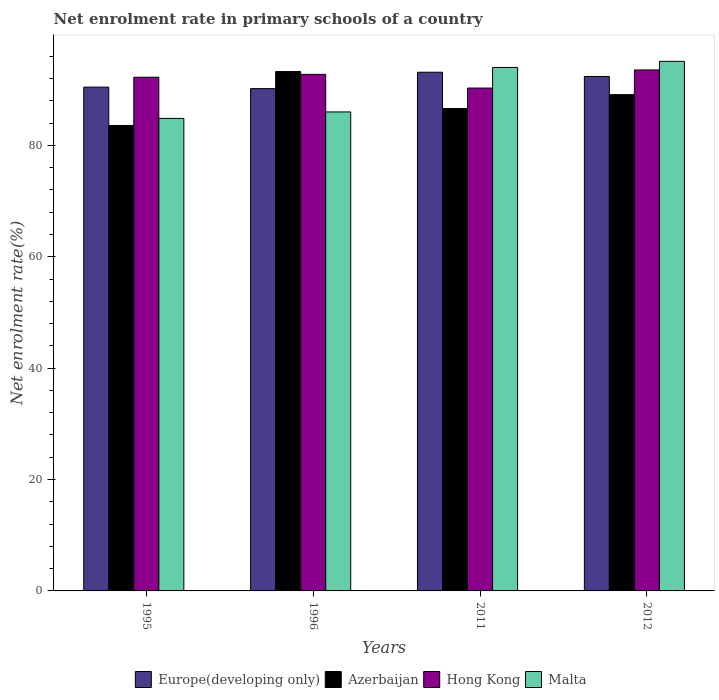How many groups of bars are there?
Provide a short and direct response. 4. Are the number of bars on each tick of the X-axis equal?
Ensure brevity in your answer.  Yes. What is the net enrolment rate in primary schools in Europe(developing only) in 2011?
Keep it short and to the point. 93.13. Across all years, what is the maximum net enrolment rate in primary schools in Hong Kong?
Make the answer very short. 93.54. Across all years, what is the minimum net enrolment rate in primary schools in Azerbaijan?
Provide a succinct answer. 83.57. In which year was the net enrolment rate in primary schools in Malta maximum?
Offer a terse response. 2012. In which year was the net enrolment rate in primary schools in Hong Kong minimum?
Your answer should be very brief. 2011. What is the total net enrolment rate in primary schools in Malta in the graph?
Offer a terse response. 359.91. What is the difference between the net enrolment rate in primary schools in Azerbaijan in 2011 and that in 2012?
Your answer should be compact. -2.49. What is the difference between the net enrolment rate in primary schools in Europe(developing only) in 2011 and the net enrolment rate in primary schools in Hong Kong in 2012?
Make the answer very short. -0.41. What is the average net enrolment rate in primary schools in Hong Kong per year?
Offer a terse response. 92.2. In the year 2011, what is the difference between the net enrolment rate in primary schools in Europe(developing only) and net enrolment rate in primary schools in Azerbaijan?
Ensure brevity in your answer.  6.52. What is the ratio of the net enrolment rate in primary schools in Malta in 1995 to that in 1996?
Offer a very short reply. 0.99. Is the difference between the net enrolment rate in primary schools in Europe(developing only) in 1996 and 2011 greater than the difference between the net enrolment rate in primary schools in Azerbaijan in 1996 and 2011?
Offer a very short reply. No. What is the difference between the highest and the second highest net enrolment rate in primary schools in Hong Kong?
Give a very brief answer. 0.79. What is the difference between the highest and the lowest net enrolment rate in primary schools in Malta?
Your response must be concise. 10.24. In how many years, is the net enrolment rate in primary schools in Malta greater than the average net enrolment rate in primary schools in Malta taken over all years?
Your response must be concise. 2. Is the sum of the net enrolment rate in primary schools in Malta in 1996 and 2011 greater than the maximum net enrolment rate in primary schools in Hong Kong across all years?
Your answer should be very brief. Yes. What does the 2nd bar from the left in 2012 represents?
Offer a very short reply. Azerbaijan. What does the 3rd bar from the right in 1995 represents?
Ensure brevity in your answer.  Azerbaijan. How many bars are there?
Offer a very short reply. 16. What is the difference between two consecutive major ticks on the Y-axis?
Your answer should be very brief. 20. Where does the legend appear in the graph?
Give a very brief answer. Bottom center. What is the title of the graph?
Make the answer very short. Net enrolment rate in primary schools of a country. What is the label or title of the Y-axis?
Provide a short and direct response. Net enrolment rate(%). What is the Net enrolment rate(%) of Europe(developing only) in 1995?
Make the answer very short. 90.46. What is the Net enrolment rate(%) of Azerbaijan in 1995?
Provide a succinct answer. 83.57. What is the Net enrolment rate(%) in Hong Kong in 1995?
Give a very brief answer. 92.23. What is the Net enrolment rate(%) in Malta in 1995?
Provide a succinct answer. 84.84. What is the Net enrolment rate(%) of Europe(developing only) in 1996?
Ensure brevity in your answer.  90.19. What is the Net enrolment rate(%) in Azerbaijan in 1996?
Ensure brevity in your answer.  93.25. What is the Net enrolment rate(%) of Hong Kong in 1996?
Provide a succinct answer. 92.74. What is the Net enrolment rate(%) in Malta in 1996?
Provide a succinct answer. 86. What is the Net enrolment rate(%) of Europe(developing only) in 2011?
Offer a very short reply. 93.13. What is the Net enrolment rate(%) in Azerbaijan in 2011?
Ensure brevity in your answer.  86.61. What is the Net enrolment rate(%) in Hong Kong in 2011?
Provide a short and direct response. 90.29. What is the Net enrolment rate(%) in Malta in 2011?
Keep it short and to the point. 93.99. What is the Net enrolment rate(%) of Europe(developing only) in 2012?
Your answer should be very brief. 92.37. What is the Net enrolment rate(%) in Azerbaijan in 2012?
Make the answer very short. 89.11. What is the Net enrolment rate(%) of Hong Kong in 2012?
Keep it short and to the point. 93.54. What is the Net enrolment rate(%) in Malta in 2012?
Offer a terse response. 95.08. Across all years, what is the maximum Net enrolment rate(%) in Europe(developing only)?
Make the answer very short. 93.13. Across all years, what is the maximum Net enrolment rate(%) in Azerbaijan?
Offer a terse response. 93.25. Across all years, what is the maximum Net enrolment rate(%) in Hong Kong?
Provide a succinct answer. 93.54. Across all years, what is the maximum Net enrolment rate(%) of Malta?
Your answer should be very brief. 95.08. Across all years, what is the minimum Net enrolment rate(%) of Europe(developing only)?
Provide a succinct answer. 90.19. Across all years, what is the minimum Net enrolment rate(%) in Azerbaijan?
Make the answer very short. 83.57. Across all years, what is the minimum Net enrolment rate(%) in Hong Kong?
Your answer should be very brief. 90.29. Across all years, what is the minimum Net enrolment rate(%) in Malta?
Make the answer very short. 84.84. What is the total Net enrolment rate(%) of Europe(developing only) in the graph?
Make the answer very short. 366.14. What is the total Net enrolment rate(%) of Azerbaijan in the graph?
Offer a terse response. 352.55. What is the total Net enrolment rate(%) of Hong Kong in the graph?
Provide a short and direct response. 368.8. What is the total Net enrolment rate(%) in Malta in the graph?
Your answer should be compact. 359.91. What is the difference between the Net enrolment rate(%) in Europe(developing only) in 1995 and that in 1996?
Provide a succinct answer. 0.27. What is the difference between the Net enrolment rate(%) in Azerbaijan in 1995 and that in 1996?
Ensure brevity in your answer.  -9.68. What is the difference between the Net enrolment rate(%) of Hong Kong in 1995 and that in 1996?
Provide a short and direct response. -0.51. What is the difference between the Net enrolment rate(%) of Malta in 1995 and that in 1996?
Offer a terse response. -1.16. What is the difference between the Net enrolment rate(%) of Europe(developing only) in 1995 and that in 2011?
Ensure brevity in your answer.  -2.67. What is the difference between the Net enrolment rate(%) of Azerbaijan in 1995 and that in 2011?
Ensure brevity in your answer.  -3.04. What is the difference between the Net enrolment rate(%) in Hong Kong in 1995 and that in 2011?
Make the answer very short. 1.95. What is the difference between the Net enrolment rate(%) in Malta in 1995 and that in 2011?
Ensure brevity in your answer.  -9.15. What is the difference between the Net enrolment rate(%) in Europe(developing only) in 1995 and that in 2012?
Keep it short and to the point. -1.91. What is the difference between the Net enrolment rate(%) of Azerbaijan in 1995 and that in 2012?
Keep it short and to the point. -5.53. What is the difference between the Net enrolment rate(%) in Hong Kong in 1995 and that in 2012?
Provide a succinct answer. -1.3. What is the difference between the Net enrolment rate(%) of Malta in 1995 and that in 2012?
Your answer should be very brief. -10.24. What is the difference between the Net enrolment rate(%) of Europe(developing only) in 1996 and that in 2011?
Offer a terse response. -2.94. What is the difference between the Net enrolment rate(%) in Azerbaijan in 1996 and that in 2011?
Make the answer very short. 6.64. What is the difference between the Net enrolment rate(%) in Hong Kong in 1996 and that in 2011?
Offer a very short reply. 2.46. What is the difference between the Net enrolment rate(%) in Malta in 1996 and that in 2011?
Make the answer very short. -7.98. What is the difference between the Net enrolment rate(%) of Europe(developing only) in 1996 and that in 2012?
Make the answer very short. -2.18. What is the difference between the Net enrolment rate(%) in Azerbaijan in 1996 and that in 2012?
Give a very brief answer. 4.15. What is the difference between the Net enrolment rate(%) in Hong Kong in 1996 and that in 2012?
Make the answer very short. -0.79. What is the difference between the Net enrolment rate(%) of Malta in 1996 and that in 2012?
Keep it short and to the point. -9.08. What is the difference between the Net enrolment rate(%) in Europe(developing only) in 2011 and that in 2012?
Offer a terse response. 0.76. What is the difference between the Net enrolment rate(%) in Azerbaijan in 2011 and that in 2012?
Keep it short and to the point. -2.49. What is the difference between the Net enrolment rate(%) of Hong Kong in 2011 and that in 2012?
Make the answer very short. -3.25. What is the difference between the Net enrolment rate(%) of Malta in 2011 and that in 2012?
Keep it short and to the point. -1.1. What is the difference between the Net enrolment rate(%) of Europe(developing only) in 1995 and the Net enrolment rate(%) of Azerbaijan in 1996?
Make the answer very short. -2.79. What is the difference between the Net enrolment rate(%) of Europe(developing only) in 1995 and the Net enrolment rate(%) of Hong Kong in 1996?
Ensure brevity in your answer.  -2.28. What is the difference between the Net enrolment rate(%) of Europe(developing only) in 1995 and the Net enrolment rate(%) of Malta in 1996?
Your answer should be very brief. 4.46. What is the difference between the Net enrolment rate(%) of Azerbaijan in 1995 and the Net enrolment rate(%) of Hong Kong in 1996?
Provide a short and direct response. -9.17. What is the difference between the Net enrolment rate(%) in Azerbaijan in 1995 and the Net enrolment rate(%) in Malta in 1996?
Ensure brevity in your answer.  -2.43. What is the difference between the Net enrolment rate(%) of Hong Kong in 1995 and the Net enrolment rate(%) of Malta in 1996?
Give a very brief answer. 6.23. What is the difference between the Net enrolment rate(%) of Europe(developing only) in 1995 and the Net enrolment rate(%) of Azerbaijan in 2011?
Make the answer very short. 3.85. What is the difference between the Net enrolment rate(%) of Europe(developing only) in 1995 and the Net enrolment rate(%) of Hong Kong in 2011?
Your answer should be very brief. 0.17. What is the difference between the Net enrolment rate(%) in Europe(developing only) in 1995 and the Net enrolment rate(%) in Malta in 2011?
Make the answer very short. -3.53. What is the difference between the Net enrolment rate(%) in Azerbaijan in 1995 and the Net enrolment rate(%) in Hong Kong in 2011?
Keep it short and to the point. -6.71. What is the difference between the Net enrolment rate(%) of Azerbaijan in 1995 and the Net enrolment rate(%) of Malta in 2011?
Give a very brief answer. -10.41. What is the difference between the Net enrolment rate(%) of Hong Kong in 1995 and the Net enrolment rate(%) of Malta in 2011?
Offer a very short reply. -1.75. What is the difference between the Net enrolment rate(%) of Europe(developing only) in 1995 and the Net enrolment rate(%) of Azerbaijan in 2012?
Provide a short and direct response. 1.35. What is the difference between the Net enrolment rate(%) in Europe(developing only) in 1995 and the Net enrolment rate(%) in Hong Kong in 2012?
Ensure brevity in your answer.  -3.08. What is the difference between the Net enrolment rate(%) of Europe(developing only) in 1995 and the Net enrolment rate(%) of Malta in 2012?
Offer a terse response. -4.62. What is the difference between the Net enrolment rate(%) of Azerbaijan in 1995 and the Net enrolment rate(%) of Hong Kong in 2012?
Ensure brevity in your answer.  -9.96. What is the difference between the Net enrolment rate(%) of Azerbaijan in 1995 and the Net enrolment rate(%) of Malta in 2012?
Provide a succinct answer. -11.51. What is the difference between the Net enrolment rate(%) of Hong Kong in 1995 and the Net enrolment rate(%) of Malta in 2012?
Give a very brief answer. -2.85. What is the difference between the Net enrolment rate(%) of Europe(developing only) in 1996 and the Net enrolment rate(%) of Azerbaijan in 2011?
Provide a short and direct response. 3.57. What is the difference between the Net enrolment rate(%) in Europe(developing only) in 1996 and the Net enrolment rate(%) in Hong Kong in 2011?
Offer a terse response. -0.1. What is the difference between the Net enrolment rate(%) of Europe(developing only) in 1996 and the Net enrolment rate(%) of Malta in 2011?
Offer a very short reply. -3.8. What is the difference between the Net enrolment rate(%) in Azerbaijan in 1996 and the Net enrolment rate(%) in Hong Kong in 2011?
Make the answer very short. 2.97. What is the difference between the Net enrolment rate(%) in Azerbaijan in 1996 and the Net enrolment rate(%) in Malta in 2011?
Provide a short and direct response. -0.73. What is the difference between the Net enrolment rate(%) in Hong Kong in 1996 and the Net enrolment rate(%) in Malta in 2011?
Keep it short and to the point. -1.24. What is the difference between the Net enrolment rate(%) in Europe(developing only) in 1996 and the Net enrolment rate(%) in Azerbaijan in 2012?
Your response must be concise. 1.08. What is the difference between the Net enrolment rate(%) in Europe(developing only) in 1996 and the Net enrolment rate(%) in Hong Kong in 2012?
Offer a very short reply. -3.35. What is the difference between the Net enrolment rate(%) of Europe(developing only) in 1996 and the Net enrolment rate(%) of Malta in 2012?
Make the answer very short. -4.9. What is the difference between the Net enrolment rate(%) of Azerbaijan in 1996 and the Net enrolment rate(%) of Hong Kong in 2012?
Provide a succinct answer. -0.28. What is the difference between the Net enrolment rate(%) of Azerbaijan in 1996 and the Net enrolment rate(%) of Malta in 2012?
Make the answer very short. -1.83. What is the difference between the Net enrolment rate(%) of Hong Kong in 1996 and the Net enrolment rate(%) of Malta in 2012?
Give a very brief answer. -2.34. What is the difference between the Net enrolment rate(%) of Europe(developing only) in 2011 and the Net enrolment rate(%) of Azerbaijan in 2012?
Ensure brevity in your answer.  4.02. What is the difference between the Net enrolment rate(%) of Europe(developing only) in 2011 and the Net enrolment rate(%) of Hong Kong in 2012?
Your answer should be very brief. -0.41. What is the difference between the Net enrolment rate(%) in Europe(developing only) in 2011 and the Net enrolment rate(%) in Malta in 2012?
Your answer should be very brief. -1.95. What is the difference between the Net enrolment rate(%) in Azerbaijan in 2011 and the Net enrolment rate(%) in Hong Kong in 2012?
Give a very brief answer. -6.92. What is the difference between the Net enrolment rate(%) in Azerbaijan in 2011 and the Net enrolment rate(%) in Malta in 2012?
Keep it short and to the point. -8.47. What is the difference between the Net enrolment rate(%) in Hong Kong in 2011 and the Net enrolment rate(%) in Malta in 2012?
Provide a succinct answer. -4.8. What is the average Net enrolment rate(%) of Europe(developing only) per year?
Keep it short and to the point. 91.54. What is the average Net enrolment rate(%) in Azerbaijan per year?
Your answer should be compact. 88.14. What is the average Net enrolment rate(%) of Hong Kong per year?
Ensure brevity in your answer.  92.2. What is the average Net enrolment rate(%) of Malta per year?
Offer a very short reply. 89.98. In the year 1995, what is the difference between the Net enrolment rate(%) in Europe(developing only) and Net enrolment rate(%) in Azerbaijan?
Keep it short and to the point. 6.89. In the year 1995, what is the difference between the Net enrolment rate(%) in Europe(developing only) and Net enrolment rate(%) in Hong Kong?
Give a very brief answer. -1.77. In the year 1995, what is the difference between the Net enrolment rate(%) in Europe(developing only) and Net enrolment rate(%) in Malta?
Offer a terse response. 5.62. In the year 1995, what is the difference between the Net enrolment rate(%) in Azerbaijan and Net enrolment rate(%) in Hong Kong?
Make the answer very short. -8.66. In the year 1995, what is the difference between the Net enrolment rate(%) in Azerbaijan and Net enrolment rate(%) in Malta?
Offer a very short reply. -1.27. In the year 1995, what is the difference between the Net enrolment rate(%) of Hong Kong and Net enrolment rate(%) of Malta?
Make the answer very short. 7.39. In the year 1996, what is the difference between the Net enrolment rate(%) of Europe(developing only) and Net enrolment rate(%) of Azerbaijan?
Ensure brevity in your answer.  -3.07. In the year 1996, what is the difference between the Net enrolment rate(%) of Europe(developing only) and Net enrolment rate(%) of Hong Kong?
Your answer should be very brief. -2.56. In the year 1996, what is the difference between the Net enrolment rate(%) of Europe(developing only) and Net enrolment rate(%) of Malta?
Your answer should be compact. 4.18. In the year 1996, what is the difference between the Net enrolment rate(%) in Azerbaijan and Net enrolment rate(%) in Hong Kong?
Your response must be concise. 0.51. In the year 1996, what is the difference between the Net enrolment rate(%) of Azerbaijan and Net enrolment rate(%) of Malta?
Keep it short and to the point. 7.25. In the year 1996, what is the difference between the Net enrolment rate(%) of Hong Kong and Net enrolment rate(%) of Malta?
Your response must be concise. 6.74. In the year 2011, what is the difference between the Net enrolment rate(%) of Europe(developing only) and Net enrolment rate(%) of Azerbaijan?
Ensure brevity in your answer.  6.52. In the year 2011, what is the difference between the Net enrolment rate(%) in Europe(developing only) and Net enrolment rate(%) in Hong Kong?
Provide a short and direct response. 2.84. In the year 2011, what is the difference between the Net enrolment rate(%) in Europe(developing only) and Net enrolment rate(%) in Malta?
Offer a terse response. -0.86. In the year 2011, what is the difference between the Net enrolment rate(%) of Azerbaijan and Net enrolment rate(%) of Hong Kong?
Provide a short and direct response. -3.67. In the year 2011, what is the difference between the Net enrolment rate(%) of Azerbaijan and Net enrolment rate(%) of Malta?
Provide a short and direct response. -7.37. In the year 2011, what is the difference between the Net enrolment rate(%) in Hong Kong and Net enrolment rate(%) in Malta?
Your answer should be compact. -3.7. In the year 2012, what is the difference between the Net enrolment rate(%) of Europe(developing only) and Net enrolment rate(%) of Azerbaijan?
Give a very brief answer. 3.26. In the year 2012, what is the difference between the Net enrolment rate(%) of Europe(developing only) and Net enrolment rate(%) of Hong Kong?
Keep it short and to the point. -1.17. In the year 2012, what is the difference between the Net enrolment rate(%) in Europe(developing only) and Net enrolment rate(%) in Malta?
Your answer should be compact. -2.71. In the year 2012, what is the difference between the Net enrolment rate(%) in Azerbaijan and Net enrolment rate(%) in Hong Kong?
Provide a short and direct response. -4.43. In the year 2012, what is the difference between the Net enrolment rate(%) of Azerbaijan and Net enrolment rate(%) of Malta?
Offer a terse response. -5.98. In the year 2012, what is the difference between the Net enrolment rate(%) in Hong Kong and Net enrolment rate(%) in Malta?
Provide a succinct answer. -1.54. What is the ratio of the Net enrolment rate(%) of Azerbaijan in 1995 to that in 1996?
Give a very brief answer. 0.9. What is the ratio of the Net enrolment rate(%) in Malta in 1995 to that in 1996?
Ensure brevity in your answer.  0.99. What is the ratio of the Net enrolment rate(%) in Europe(developing only) in 1995 to that in 2011?
Provide a succinct answer. 0.97. What is the ratio of the Net enrolment rate(%) in Azerbaijan in 1995 to that in 2011?
Keep it short and to the point. 0.96. What is the ratio of the Net enrolment rate(%) of Hong Kong in 1995 to that in 2011?
Your answer should be compact. 1.02. What is the ratio of the Net enrolment rate(%) in Malta in 1995 to that in 2011?
Ensure brevity in your answer.  0.9. What is the ratio of the Net enrolment rate(%) of Europe(developing only) in 1995 to that in 2012?
Your answer should be very brief. 0.98. What is the ratio of the Net enrolment rate(%) of Azerbaijan in 1995 to that in 2012?
Provide a succinct answer. 0.94. What is the ratio of the Net enrolment rate(%) of Hong Kong in 1995 to that in 2012?
Your response must be concise. 0.99. What is the ratio of the Net enrolment rate(%) in Malta in 1995 to that in 2012?
Your answer should be very brief. 0.89. What is the ratio of the Net enrolment rate(%) of Europe(developing only) in 1996 to that in 2011?
Keep it short and to the point. 0.97. What is the ratio of the Net enrolment rate(%) in Azerbaijan in 1996 to that in 2011?
Keep it short and to the point. 1.08. What is the ratio of the Net enrolment rate(%) of Hong Kong in 1996 to that in 2011?
Provide a short and direct response. 1.03. What is the ratio of the Net enrolment rate(%) in Malta in 1996 to that in 2011?
Your response must be concise. 0.92. What is the ratio of the Net enrolment rate(%) in Europe(developing only) in 1996 to that in 2012?
Your answer should be compact. 0.98. What is the ratio of the Net enrolment rate(%) in Azerbaijan in 1996 to that in 2012?
Keep it short and to the point. 1.05. What is the ratio of the Net enrolment rate(%) of Malta in 1996 to that in 2012?
Offer a terse response. 0.9. What is the ratio of the Net enrolment rate(%) of Europe(developing only) in 2011 to that in 2012?
Offer a terse response. 1.01. What is the ratio of the Net enrolment rate(%) of Hong Kong in 2011 to that in 2012?
Provide a succinct answer. 0.97. What is the difference between the highest and the second highest Net enrolment rate(%) in Europe(developing only)?
Provide a succinct answer. 0.76. What is the difference between the highest and the second highest Net enrolment rate(%) in Azerbaijan?
Give a very brief answer. 4.15. What is the difference between the highest and the second highest Net enrolment rate(%) in Hong Kong?
Offer a very short reply. 0.79. What is the difference between the highest and the second highest Net enrolment rate(%) of Malta?
Your answer should be very brief. 1.1. What is the difference between the highest and the lowest Net enrolment rate(%) of Europe(developing only)?
Give a very brief answer. 2.94. What is the difference between the highest and the lowest Net enrolment rate(%) in Azerbaijan?
Give a very brief answer. 9.68. What is the difference between the highest and the lowest Net enrolment rate(%) of Hong Kong?
Provide a short and direct response. 3.25. What is the difference between the highest and the lowest Net enrolment rate(%) of Malta?
Give a very brief answer. 10.24. 